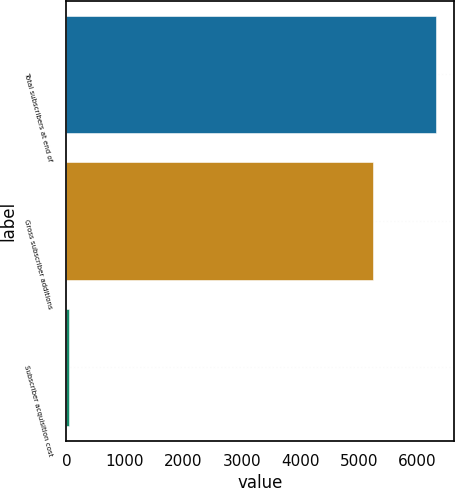<chart> <loc_0><loc_0><loc_500><loc_500><bar_chart><fcel>Total subscribers at end of<fcel>Gross subscriber additions<fcel>Subscriber acquisition cost<nl><fcel>6316<fcel>5250<fcel>42.94<nl></chart> 